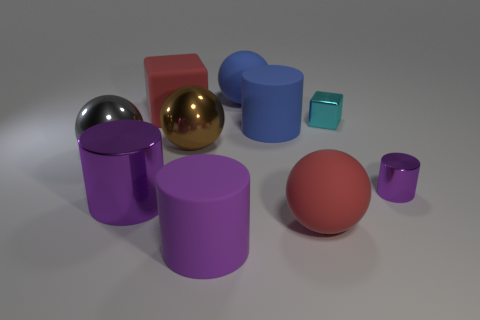Subtract all gray blocks. How many purple cylinders are left? 3 Subtract 2 cylinders. How many cylinders are left? 2 Subtract all gray metallic spheres. How many spheres are left? 3 Subtract all blue balls. How many balls are left? 3 Subtract all brown cylinders. Subtract all blue cubes. How many cylinders are left? 4 Subtract all spheres. How many objects are left? 6 Subtract 1 red blocks. How many objects are left? 9 Subtract all big metal cylinders. Subtract all tiny purple metal things. How many objects are left? 8 Add 6 large purple cylinders. How many large purple cylinders are left? 8 Add 5 big rubber balls. How many big rubber balls exist? 7 